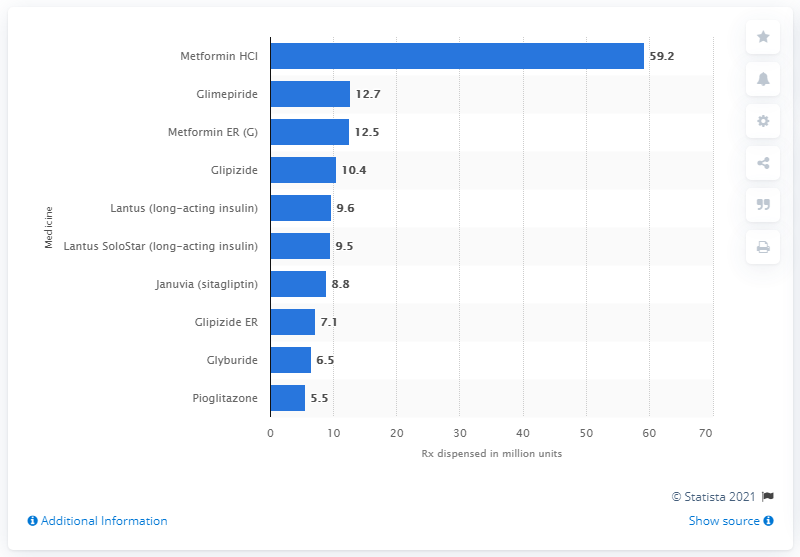Draw attention to some important aspects in this diagram. In 2014, a total of 59.2 units of Metformin HCI were dispensed. In 2014, the most commonly prescribed diabetes medication in the United States was metformin hydrochloride, according to data. 